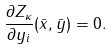<formula> <loc_0><loc_0><loc_500><loc_500>\frac { \partial Z _ { \kappa } } { \partial y _ { i } } ( \bar { x } , \bar { y } ) = 0 .</formula> 